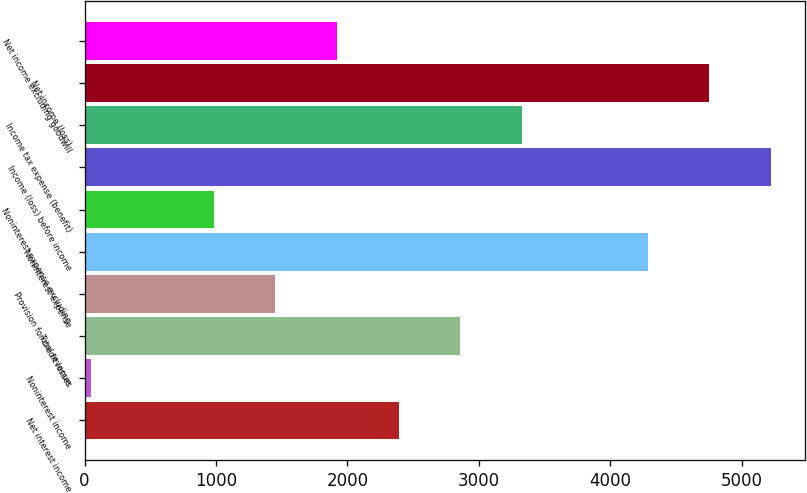Convert chart. <chart><loc_0><loc_0><loc_500><loc_500><bar_chart><fcel>Net interest income<fcel>Noninterest income<fcel>Total revenue<fcel>Provision for credit losses<fcel>Noninterest expense<fcel>Noninterest expense excluding<fcel>Income (loss) before income<fcel>Income tax expense (benefit)<fcel>Net income (loss)<fcel>Net income excluding goodwill<nl><fcel>2391<fcel>46<fcel>2860<fcel>1453<fcel>4287<fcel>984<fcel>5225<fcel>3329<fcel>4756<fcel>1922<nl></chart> 